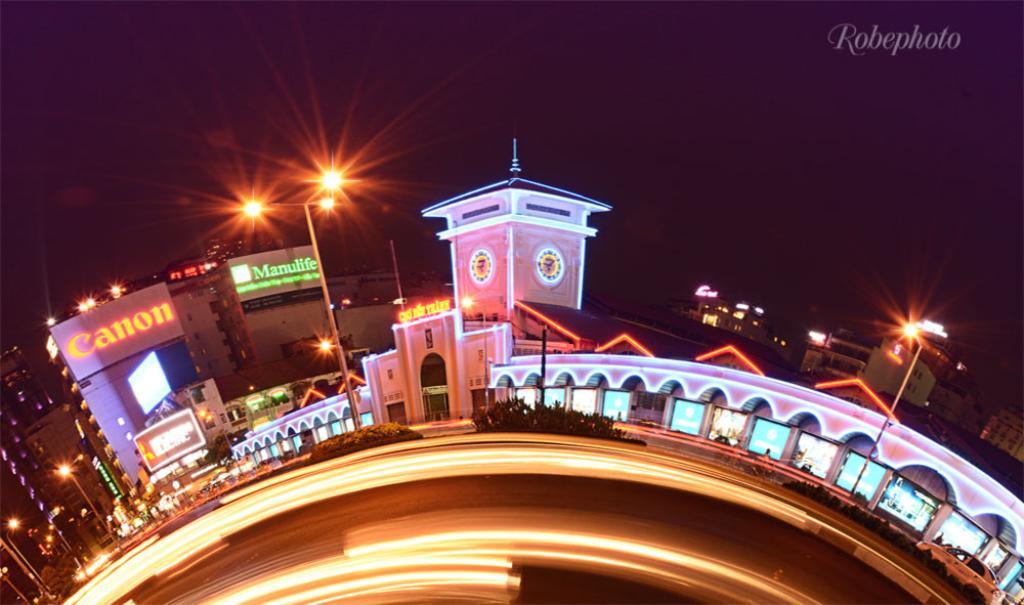What is the camera company on display?
Your response must be concise. Canon. What brand is lit up on the left?
Provide a succinct answer. Canon. 